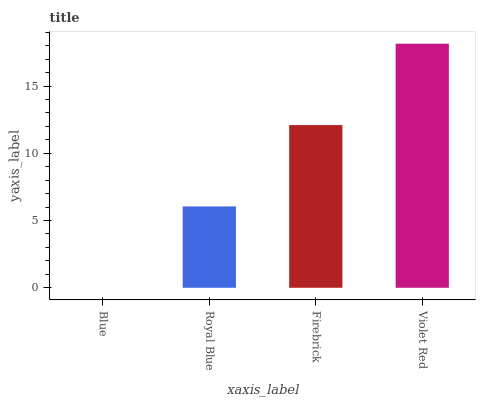Is Blue the minimum?
Answer yes or no. Yes. Is Violet Red the maximum?
Answer yes or no. Yes. Is Royal Blue the minimum?
Answer yes or no. No. Is Royal Blue the maximum?
Answer yes or no. No. Is Royal Blue greater than Blue?
Answer yes or no. Yes. Is Blue less than Royal Blue?
Answer yes or no. Yes. Is Blue greater than Royal Blue?
Answer yes or no. No. Is Royal Blue less than Blue?
Answer yes or no. No. Is Firebrick the high median?
Answer yes or no. Yes. Is Royal Blue the low median?
Answer yes or no. Yes. Is Violet Red the high median?
Answer yes or no. No. Is Firebrick the low median?
Answer yes or no. No. 